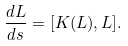Convert formula to latex. <formula><loc_0><loc_0><loc_500><loc_500>\frac { d L } { d s } = [ K ( L ) , L ] .</formula> 